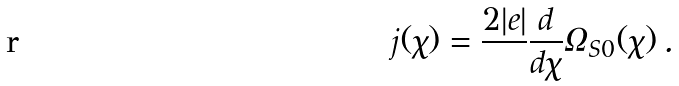Convert formula to latex. <formula><loc_0><loc_0><loc_500><loc_500>j ( \chi ) = \frac { 2 | e | } { } \frac { d } { d \chi } { \mathit \varOmega } _ { S 0 } ( \chi ) \, .</formula> 